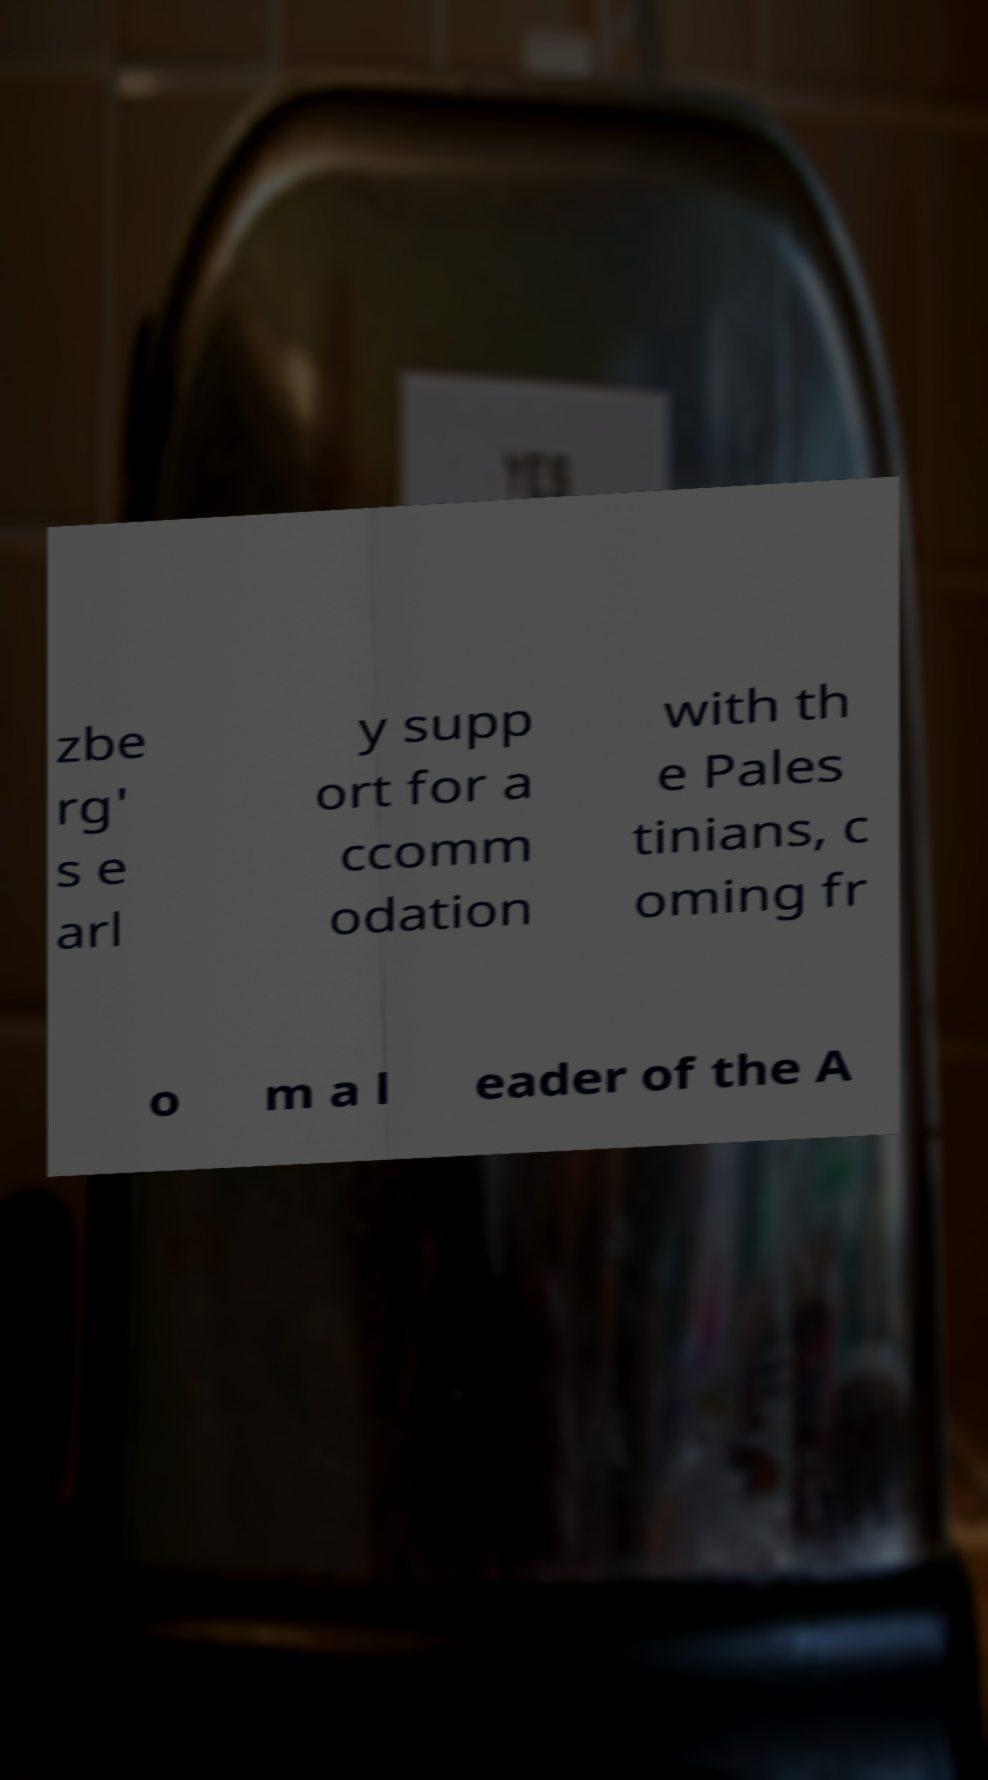Please read and relay the text visible in this image. What does it say? zbe rg' s e arl y supp ort for a ccomm odation with th e Pales tinians, c oming fr o m a l eader of the A 